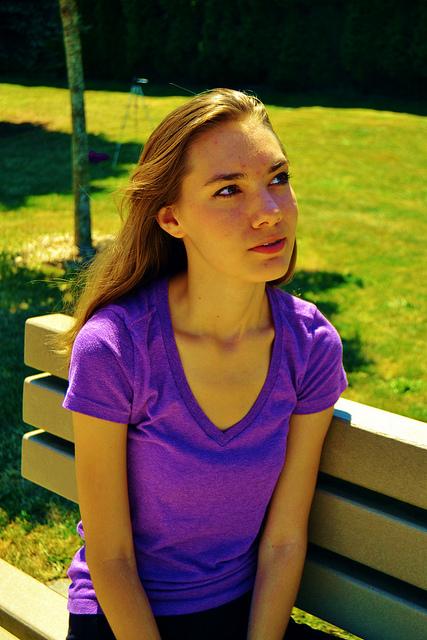Is the weather sunny today?
Keep it brief. Yes. Is this female young or mature?
Write a very short answer. Young. Is she a toddler?
Short answer required. No. What type of seat is behind the girl?
Concise answer only. Bench. What pattern is the girl's shirt?
Quick response, please. Solid. What color is the woman's shirt?
Quick response, please. Purple. Is the woman talking on her cell phone?
Write a very short answer. No. Is this woman smiling?
Answer briefly. No. Is this girl an adult?
Write a very short answer. No. What kinds of sounds do these animals make?
Be succinct. Speaking. 